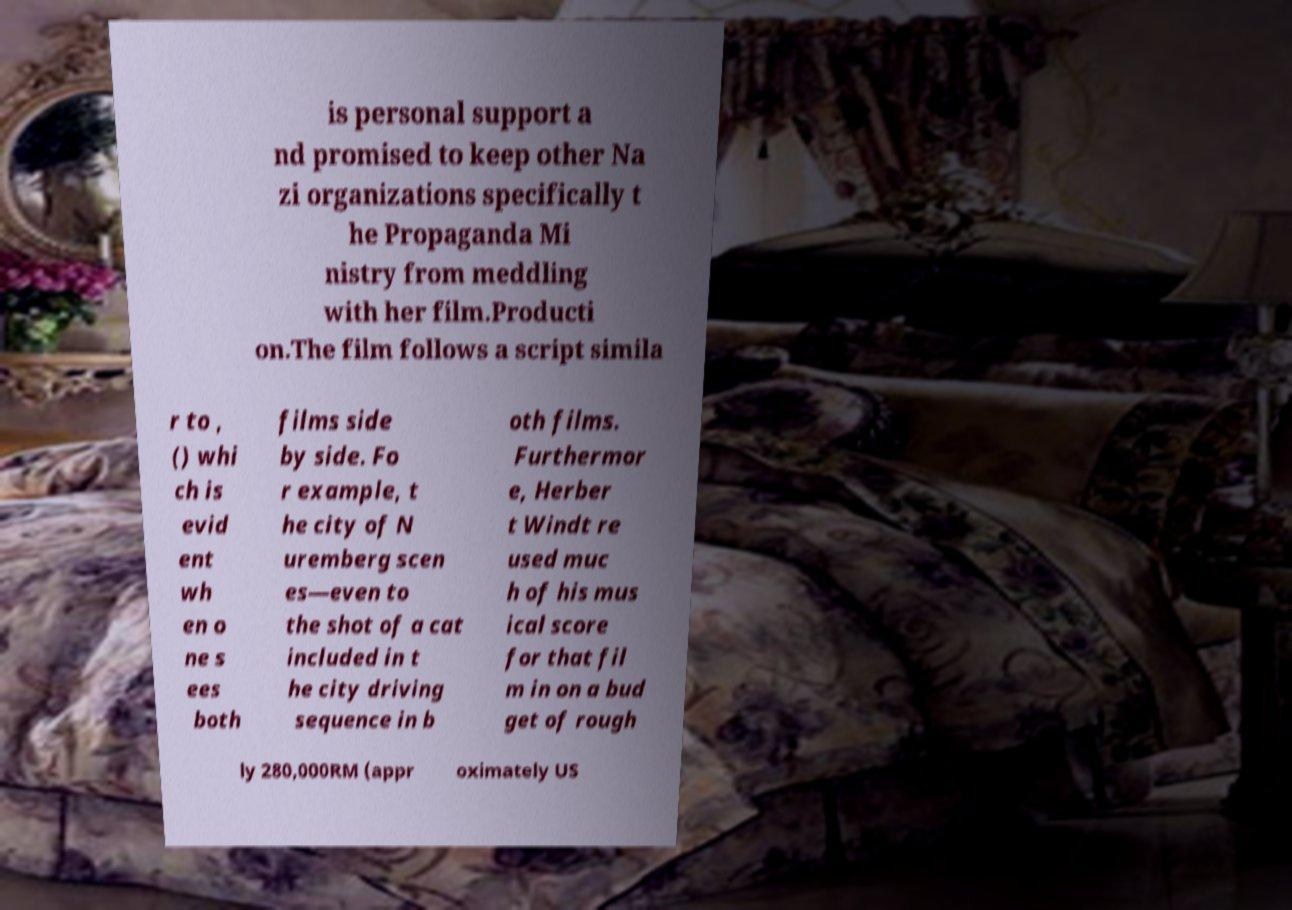There's text embedded in this image that I need extracted. Can you transcribe it verbatim? is personal support a nd promised to keep other Na zi organizations specifically t he Propaganda Mi nistry from meddling with her film.Producti on.The film follows a script simila r to , () whi ch is evid ent wh en o ne s ees both films side by side. Fo r example, t he city of N uremberg scen es—even to the shot of a cat included in t he city driving sequence in b oth films. Furthermor e, Herber t Windt re used muc h of his mus ical score for that fil m in on a bud get of rough ly 280,000RM (appr oximately US 